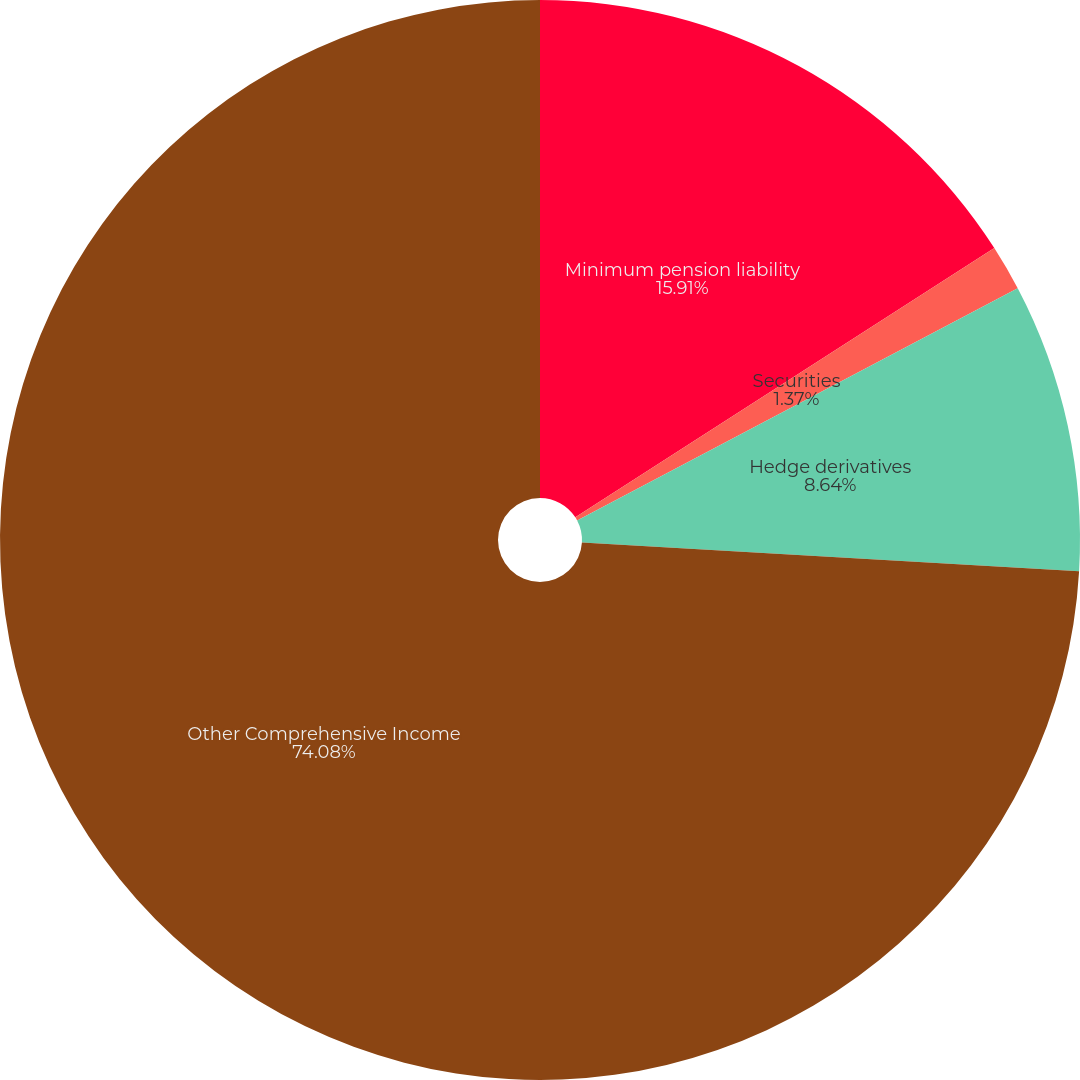<chart> <loc_0><loc_0><loc_500><loc_500><pie_chart><fcel>Minimum pension liability<fcel>Securities<fcel>Hedge derivatives<fcel>Other Comprehensive Income<nl><fcel>15.91%<fcel>1.37%<fcel>8.64%<fcel>74.08%<nl></chart> 